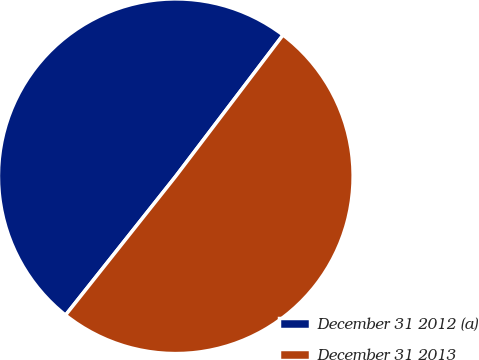Convert chart. <chart><loc_0><loc_0><loc_500><loc_500><pie_chart><fcel>December 31 2012 (a)<fcel>December 31 2013<nl><fcel>49.66%<fcel>50.34%<nl></chart> 